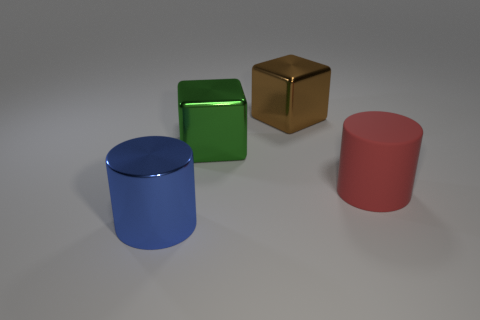Add 2 big green cubes. How many objects exist? 6 Subtract 0 red cubes. How many objects are left? 4 Subtract 2 cylinders. How many cylinders are left? 0 Subtract all brown blocks. Subtract all cyan cylinders. How many blocks are left? 1 Subtract all purple cylinders. How many blue cubes are left? 0 Subtract all large brown things. Subtract all big brown shiny blocks. How many objects are left? 2 Add 3 things. How many things are left? 7 Add 4 cyan shiny cubes. How many cyan shiny cubes exist? 4 